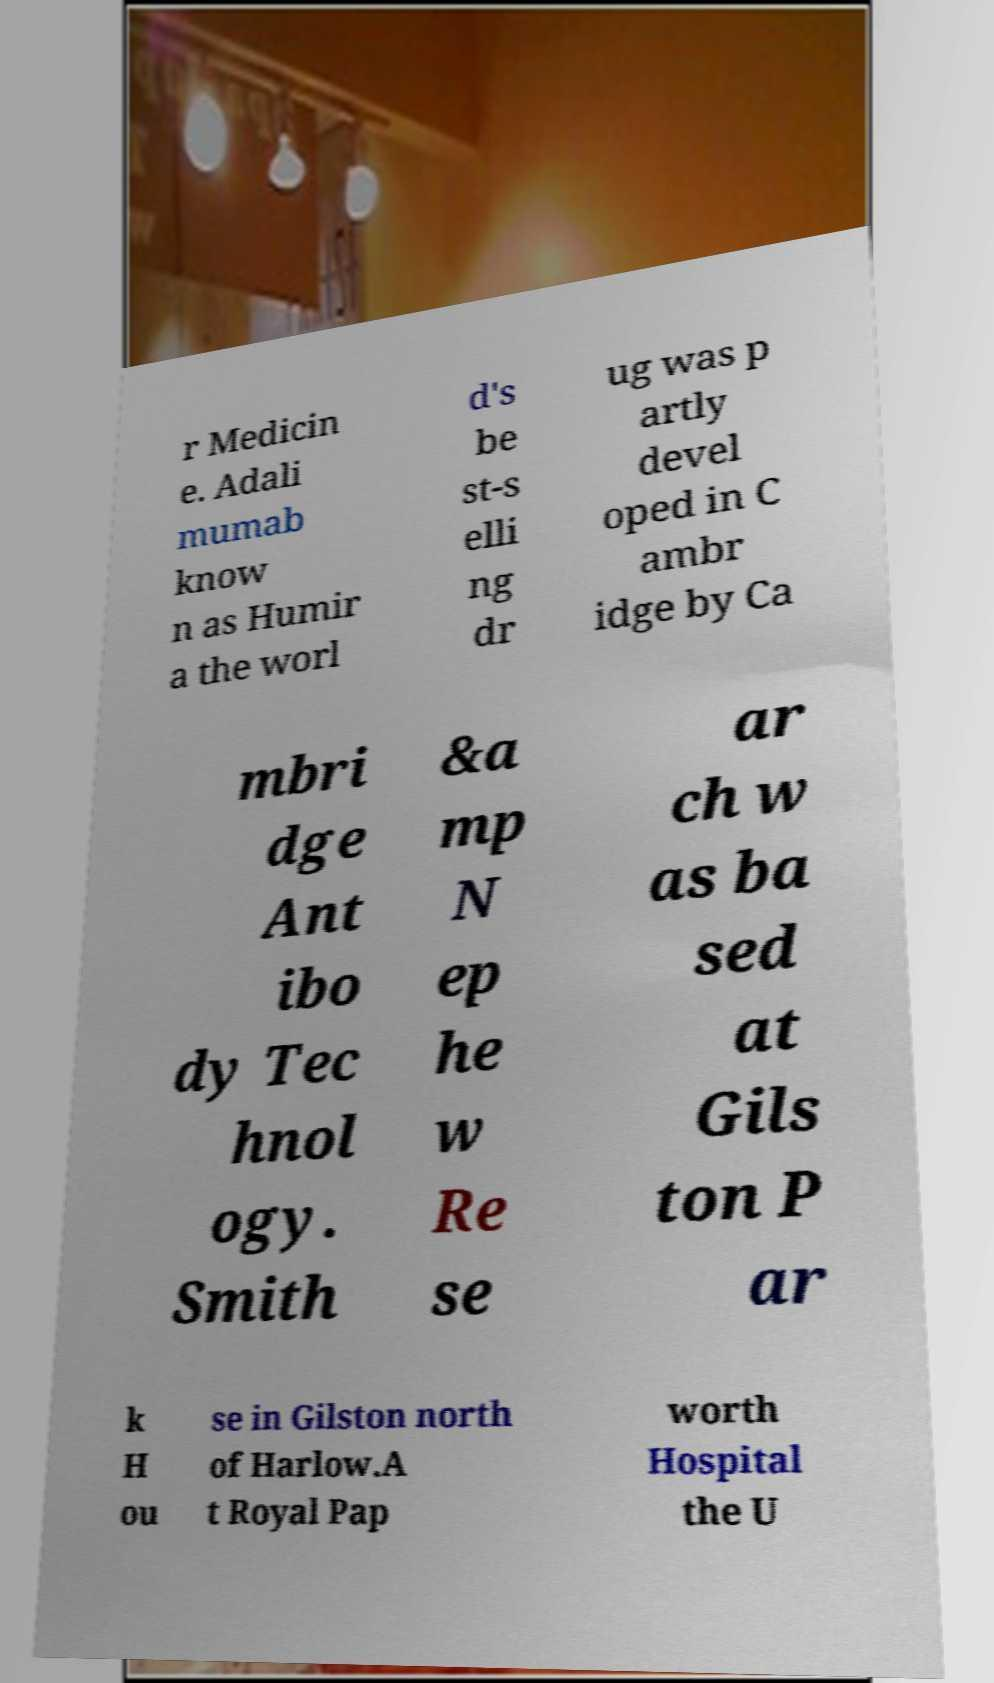Can you accurately transcribe the text from the provided image for me? r Medicin e. Adali mumab know n as Humir a the worl d's be st-s elli ng dr ug was p artly devel oped in C ambr idge by Ca mbri dge Ant ibo dy Tec hnol ogy. Smith &a mp N ep he w Re se ar ch w as ba sed at Gils ton P ar k H ou se in Gilston north of Harlow.A t Royal Pap worth Hospital the U 